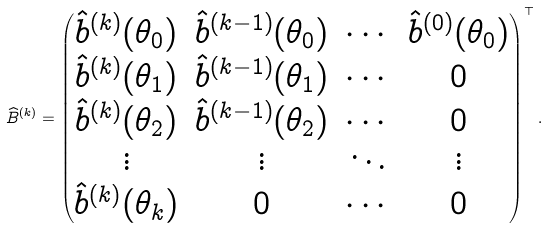<formula> <loc_0><loc_0><loc_500><loc_500>\widehat { B } ^ { ( k ) } = \begin{pmatrix} \hat { b } ^ { ( k ) } ( \theta _ { 0 } ) & \hat { b } ^ { ( k - 1 ) } ( \theta _ { 0 } ) & \cdots & \hat { b } ^ { ( 0 ) } ( \theta _ { 0 } ) \\ \hat { b } ^ { ( k ) } ( \theta _ { 1 } ) & \hat { b } ^ { ( k - 1 ) } ( \theta _ { 1 } ) & \cdots & 0 \\ \hat { b } ^ { ( k ) } ( \theta _ { 2 } ) & \hat { b } ^ { ( k - 1 ) } ( \theta _ { 2 } ) & \cdots & 0 \\ \vdots & \vdots & \ddots & \vdots \\ \hat { b } ^ { ( k ) } ( \theta _ { k } ) & 0 & \cdots & 0 \end{pmatrix} ^ { \top } .</formula> 